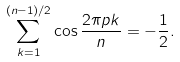Convert formula to latex. <formula><loc_0><loc_0><loc_500><loc_500>\sum _ { k = 1 } ^ { ( n - 1 ) / 2 } \cos \frac { 2 \pi p k } { n } = - \frac { 1 } { 2 } .</formula> 